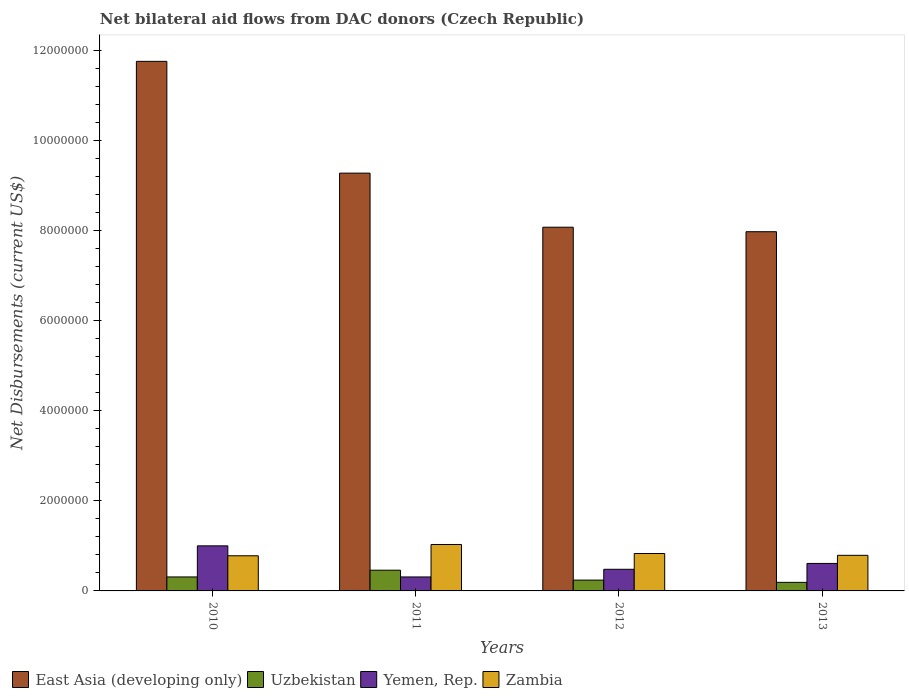How many different coloured bars are there?
Offer a terse response. 4. How many groups of bars are there?
Provide a short and direct response. 4. Are the number of bars per tick equal to the number of legend labels?
Offer a very short reply. Yes. How many bars are there on the 3rd tick from the left?
Offer a terse response. 4. What is the net bilateral aid flows in Uzbekistan in 2012?
Give a very brief answer. 2.40e+05. Across all years, what is the maximum net bilateral aid flows in East Asia (developing only)?
Make the answer very short. 1.18e+07. Across all years, what is the minimum net bilateral aid flows in Yemen, Rep.?
Provide a short and direct response. 3.10e+05. What is the total net bilateral aid flows in Zambia in the graph?
Your answer should be very brief. 3.43e+06. What is the difference between the net bilateral aid flows in East Asia (developing only) in 2010 and that in 2011?
Ensure brevity in your answer.  2.48e+06. What is the difference between the net bilateral aid flows in Yemen, Rep. in 2010 and the net bilateral aid flows in Uzbekistan in 2013?
Provide a succinct answer. 8.10e+05. What is the average net bilateral aid flows in East Asia (developing only) per year?
Your response must be concise. 9.26e+06. In the year 2011, what is the difference between the net bilateral aid flows in Zambia and net bilateral aid flows in Uzbekistan?
Offer a terse response. 5.70e+05. In how many years, is the net bilateral aid flows in Yemen, Rep. greater than 6800000 US$?
Your answer should be very brief. 0. What is the ratio of the net bilateral aid flows in Uzbekistan in 2010 to that in 2013?
Your response must be concise. 1.63. What is the difference between the highest and the lowest net bilateral aid flows in Yemen, Rep.?
Your response must be concise. 6.90e+05. In how many years, is the net bilateral aid flows in Uzbekistan greater than the average net bilateral aid flows in Uzbekistan taken over all years?
Your answer should be compact. 2. Is the sum of the net bilateral aid flows in Uzbekistan in 2010 and 2013 greater than the maximum net bilateral aid flows in East Asia (developing only) across all years?
Your answer should be very brief. No. What does the 4th bar from the left in 2010 represents?
Your answer should be compact. Zambia. What does the 3rd bar from the right in 2011 represents?
Offer a very short reply. Uzbekistan. Is it the case that in every year, the sum of the net bilateral aid flows in Yemen, Rep. and net bilateral aid flows in Zambia is greater than the net bilateral aid flows in East Asia (developing only)?
Provide a succinct answer. No. How many bars are there?
Make the answer very short. 16. How many years are there in the graph?
Your response must be concise. 4. Does the graph contain any zero values?
Your answer should be very brief. No. Where does the legend appear in the graph?
Your answer should be compact. Bottom left. How are the legend labels stacked?
Give a very brief answer. Horizontal. What is the title of the graph?
Keep it short and to the point. Net bilateral aid flows from DAC donors (Czech Republic). What is the label or title of the Y-axis?
Provide a short and direct response. Net Disbursements (current US$). What is the Net Disbursements (current US$) in East Asia (developing only) in 2010?
Your answer should be compact. 1.18e+07. What is the Net Disbursements (current US$) of Yemen, Rep. in 2010?
Ensure brevity in your answer.  1.00e+06. What is the Net Disbursements (current US$) of Zambia in 2010?
Give a very brief answer. 7.80e+05. What is the Net Disbursements (current US$) in East Asia (developing only) in 2011?
Make the answer very short. 9.27e+06. What is the Net Disbursements (current US$) of Uzbekistan in 2011?
Ensure brevity in your answer.  4.60e+05. What is the Net Disbursements (current US$) of Yemen, Rep. in 2011?
Offer a very short reply. 3.10e+05. What is the Net Disbursements (current US$) in Zambia in 2011?
Your response must be concise. 1.03e+06. What is the Net Disbursements (current US$) of East Asia (developing only) in 2012?
Your answer should be compact. 8.07e+06. What is the Net Disbursements (current US$) of Zambia in 2012?
Offer a terse response. 8.30e+05. What is the Net Disbursements (current US$) in East Asia (developing only) in 2013?
Give a very brief answer. 7.97e+06. What is the Net Disbursements (current US$) of Uzbekistan in 2013?
Offer a terse response. 1.90e+05. What is the Net Disbursements (current US$) in Zambia in 2013?
Ensure brevity in your answer.  7.90e+05. Across all years, what is the maximum Net Disbursements (current US$) of East Asia (developing only)?
Provide a short and direct response. 1.18e+07. Across all years, what is the maximum Net Disbursements (current US$) in Uzbekistan?
Offer a terse response. 4.60e+05. Across all years, what is the maximum Net Disbursements (current US$) in Yemen, Rep.?
Provide a short and direct response. 1.00e+06. Across all years, what is the maximum Net Disbursements (current US$) in Zambia?
Make the answer very short. 1.03e+06. Across all years, what is the minimum Net Disbursements (current US$) of East Asia (developing only)?
Offer a very short reply. 7.97e+06. Across all years, what is the minimum Net Disbursements (current US$) in Uzbekistan?
Ensure brevity in your answer.  1.90e+05. Across all years, what is the minimum Net Disbursements (current US$) in Zambia?
Offer a very short reply. 7.80e+05. What is the total Net Disbursements (current US$) of East Asia (developing only) in the graph?
Give a very brief answer. 3.71e+07. What is the total Net Disbursements (current US$) in Uzbekistan in the graph?
Your answer should be compact. 1.20e+06. What is the total Net Disbursements (current US$) of Yemen, Rep. in the graph?
Make the answer very short. 2.40e+06. What is the total Net Disbursements (current US$) of Zambia in the graph?
Ensure brevity in your answer.  3.43e+06. What is the difference between the Net Disbursements (current US$) in East Asia (developing only) in 2010 and that in 2011?
Give a very brief answer. 2.48e+06. What is the difference between the Net Disbursements (current US$) in Yemen, Rep. in 2010 and that in 2011?
Your answer should be compact. 6.90e+05. What is the difference between the Net Disbursements (current US$) in East Asia (developing only) in 2010 and that in 2012?
Your response must be concise. 3.68e+06. What is the difference between the Net Disbursements (current US$) in Uzbekistan in 2010 and that in 2012?
Your answer should be compact. 7.00e+04. What is the difference between the Net Disbursements (current US$) of Yemen, Rep. in 2010 and that in 2012?
Your answer should be very brief. 5.20e+05. What is the difference between the Net Disbursements (current US$) in Zambia in 2010 and that in 2012?
Provide a succinct answer. -5.00e+04. What is the difference between the Net Disbursements (current US$) in East Asia (developing only) in 2010 and that in 2013?
Ensure brevity in your answer.  3.78e+06. What is the difference between the Net Disbursements (current US$) in Zambia in 2010 and that in 2013?
Give a very brief answer. -10000. What is the difference between the Net Disbursements (current US$) in East Asia (developing only) in 2011 and that in 2012?
Your answer should be compact. 1.20e+06. What is the difference between the Net Disbursements (current US$) of Uzbekistan in 2011 and that in 2012?
Your answer should be compact. 2.20e+05. What is the difference between the Net Disbursements (current US$) of Yemen, Rep. in 2011 and that in 2012?
Provide a short and direct response. -1.70e+05. What is the difference between the Net Disbursements (current US$) of Zambia in 2011 and that in 2012?
Offer a very short reply. 2.00e+05. What is the difference between the Net Disbursements (current US$) of East Asia (developing only) in 2011 and that in 2013?
Give a very brief answer. 1.30e+06. What is the difference between the Net Disbursements (current US$) of Uzbekistan in 2011 and that in 2013?
Offer a very short reply. 2.70e+05. What is the difference between the Net Disbursements (current US$) of Zambia in 2011 and that in 2013?
Provide a succinct answer. 2.40e+05. What is the difference between the Net Disbursements (current US$) of East Asia (developing only) in 2012 and that in 2013?
Provide a succinct answer. 1.00e+05. What is the difference between the Net Disbursements (current US$) of Uzbekistan in 2012 and that in 2013?
Ensure brevity in your answer.  5.00e+04. What is the difference between the Net Disbursements (current US$) in Yemen, Rep. in 2012 and that in 2013?
Your answer should be compact. -1.30e+05. What is the difference between the Net Disbursements (current US$) of East Asia (developing only) in 2010 and the Net Disbursements (current US$) of Uzbekistan in 2011?
Your answer should be very brief. 1.13e+07. What is the difference between the Net Disbursements (current US$) in East Asia (developing only) in 2010 and the Net Disbursements (current US$) in Yemen, Rep. in 2011?
Provide a succinct answer. 1.14e+07. What is the difference between the Net Disbursements (current US$) in East Asia (developing only) in 2010 and the Net Disbursements (current US$) in Zambia in 2011?
Provide a short and direct response. 1.07e+07. What is the difference between the Net Disbursements (current US$) in Uzbekistan in 2010 and the Net Disbursements (current US$) in Zambia in 2011?
Keep it short and to the point. -7.20e+05. What is the difference between the Net Disbursements (current US$) in Yemen, Rep. in 2010 and the Net Disbursements (current US$) in Zambia in 2011?
Offer a terse response. -3.00e+04. What is the difference between the Net Disbursements (current US$) in East Asia (developing only) in 2010 and the Net Disbursements (current US$) in Uzbekistan in 2012?
Your answer should be very brief. 1.15e+07. What is the difference between the Net Disbursements (current US$) in East Asia (developing only) in 2010 and the Net Disbursements (current US$) in Yemen, Rep. in 2012?
Your answer should be compact. 1.13e+07. What is the difference between the Net Disbursements (current US$) in East Asia (developing only) in 2010 and the Net Disbursements (current US$) in Zambia in 2012?
Your answer should be compact. 1.09e+07. What is the difference between the Net Disbursements (current US$) in Uzbekistan in 2010 and the Net Disbursements (current US$) in Yemen, Rep. in 2012?
Ensure brevity in your answer.  -1.70e+05. What is the difference between the Net Disbursements (current US$) of Uzbekistan in 2010 and the Net Disbursements (current US$) of Zambia in 2012?
Ensure brevity in your answer.  -5.20e+05. What is the difference between the Net Disbursements (current US$) in Yemen, Rep. in 2010 and the Net Disbursements (current US$) in Zambia in 2012?
Provide a succinct answer. 1.70e+05. What is the difference between the Net Disbursements (current US$) of East Asia (developing only) in 2010 and the Net Disbursements (current US$) of Uzbekistan in 2013?
Your answer should be compact. 1.16e+07. What is the difference between the Net Disbursements (current US$) in East Asia (developing only) in 2010 and the Net Disbursements (current US$) in Yemen, Rep. in 2013?
Give a very brief answer. 1.11e+07. What is the difference between the Net Disbursements (current US$) in East Asia (developing only) in 2010 and the Net Disbursements (current US$) in Zambia in 2013?
Ensure brevity in your answer.  1.10e+07. What is the difference between the Net Disbursements (current US$) of Uzbekistan in 2010 and the Net Disbursements (current US$) of Yemen, Rep. in 2013?
Your response must be concise. -3.00e+05. What is the difference between the Net Disbursements (current US$) in Uzbekistan in 2010 and the Net Disbursements (current US$) in Zambia in 2013?
Offer a terse response. -4.80e+05. What is the difference between the Net Disbursements (current US$) in East Asia (developing only) in 2011 and the Net Disbursements (current US$) in Uzbekistan in 2012?
Keep it short and to the point. 9.03e+06. What is the difference between the Net Disbursements (current US$) of East Asia (developing only) in 2011 and the Net Disbursements (current US$) of Yemen, Rep. in 2012?
Provide a succinct answer. 8.79e+06. What is the difference between the Net Disbursements (current US$) of East Asia (developing only) in 2011 and the Net Disbursements (current US$) of Zambia in 2012?
Make the answer very short. 8.44e+06. What is the difference between the Net Disbursements (current US$) of Uzbekistan in 2011 and the Net Disbursements (current US$) of Zambia in 2012?
Your answer should be compact. -3.70e+05. What is the difference between the Net Disbursements (current US$) of Yemen, Rep. in 2011 and the Net Disbursements (current US$) of Zambia in 2012?
Your answer should be compact. -5.20e+05. What is the difference between the Net Disbursements (current US$) in East Asia (developing only) in 2011 and the Net Disbursements (current US$) in Uzbekistan in 2013?
Your answer should be compact. 9.08e+06. What is the difference between the Net Disbursements (current US$) in East Asia (developing only) in 2011 and the Net Disbursements (current US$) in Yemen, Rep. in 2013?
Provide a short and direct response. 8.66e+06. What is the difference between the Net Disbursements (current US$) in East Asia (developing only) in 2011 and the Net Disbursements (current US$) in Zambia in 2013?
Offer a very short reply. 8.48e+06. What is the difference between the Net Disbursements (current US$) of Uzbekistan in 2011 and the Net Disbursements (current US$) of Yemen, Rep. in 2013?
Your answer should be compact. -1.50e+05. What is the difference between the Net Disbursements (current US$) in Uzbekistan in 2011 and the Net Disbursements (current US$) in Zambia in 2013?
Offer a very short reply. -3.30e+05. What is the difference between the Net Disbursements (current US$) of Yemen, Rep. in 2011 and the Net Disbursements (current US$) of Zambia in 2013?
Ensure brevity in your answer.  -4.80e+05. What is the difference between the Net Disbursements (current US$) of East Asia (developing only) in 2012 and the Net Disbursements (current US$) of Uzbekistan in 2013?
Your answer should be compact. 7.88e+06. What is the difference between the Net Disbursements (current US$) in East Asia (developing only) in 2012 and the Net Disbursements (current US$) in Yemen, Rep. in 2013?
Offer a terse response. 7.46e+06. What is the difference between the Net Disbursements (current US$) of East Asia (developing only) in 2012 and the Net Disbursements (current US$) of Zambia in 2013?
Provide a succinct answer. 7.28e+06. What is the difference between the Net Disbursements (current US$) of Uzbekistan in 2012 and the Net Disbursements (current US$) of Yemen, Rep. in 2013?
Offer a terse response. -3.70e+05. What is the difference between the Net Disbursements (current US$) in Uzbekistan in 2012 and the Net Disbursements (current US$) in Zambia in 2013?
Ensure brevity in your answer.  -5.50e+05. What is the difference between the Net Disbursements (current US$) of Yemen, Rep. in 2012 and the Net Disbursements (current US$) of Zambia in 2013?
Make the answer very short. -3.10e+05. What is the average Net Disbursements (current US$) of East Asia (developing only) per year?
Your response must be concise. 9.26e+06. What is the average Net Disbursements (current US$) of Zambia per year?
Your answer should be compact. 8.58e+05. In the year 2010, what is the difference between the Net Disbursements (current US$) in East Asia (developing only) and Net Disbursements (current US$) in Uzbekistan?
Keep it short and to the point. 1.14e+07. In the year 2010, what is the difference between the Net Disbursements (current US$) in East Asia (developing only) and Net Disbursements (current US$) in Yemen, Rep.?
Keep it short and to the point. 1.08e+07. In the year 2010, what is the difference between the Net Disbursements (current US$) of East Asia (developing only) and Net Disbursements (current US$) of Zambia?
Ensure brevity in your answer.  1.10e+07. In the year 2010, what is the difference between the Net Disbursements (current US$) of Uzbekistan and Net Disbursements (current US$) of Yemen, Rep.?
Give a very brief answer. -6.90e+05. In the year 2010, what is the difference between the Net Disbursements (current US$) of Uzbekistan and Net Disbursements (current US$) of Zambia?
Ensure brevity in your answer.  -4.70e+05. In the year 2011, what is the difference between the Net Disbursements (current US$) of East Asia (developing only) and Net Disbursements (current US$) of Uzbekistan?
Provide a succinct answer. 8.81e+06. In the year 2011, what is the difference between the Net Disbursements (current US$) in East Asia (developing only) and Net Disbursements (current US$) in Yemen, Rep.?
Make the answer very short. 8.96e+06. In the year 2011, what is the difference between the Net Disbursements (current US$) in East Asia (developing only) and Net Disbursements (current US$) in Zambia?
Provide a short and direct response. 8.24e+06. In the year 2011, what is the difference between the Net Disbursements (current US$) of Uzbekistan and Net Disbursements (current US$) of Zambia?
Your answer should be very brief. -5.70e+05. In the year 2011, what is the difference between the Net Disbursements (current US$) of Yemen, Rep. and Net Disbursements (current US$) of Zambia?
Provide a succinct answer. -7.20e+05. In the year 2012, what is the difference between the Net Disbursements (current US$) in East Asia (developing only) and Net Disbursements (current US$) in Uzbekistan?
Your response must be concise. 7.83e+06. In the year 2012, what is the difference between the Net Disbursements (current US$) of East Asia (developing only) and Net Disbursements (current US$) of Yemen, Rep.?
Your answer should be very brief. 7.59e+06. In the year 2012, what is the difference between the Net Disbursements (current US$) of East Asia (developing only) and Net Disbursements (current US$) of Zambia?
Offer a very short reply. 7.24e+06. In the year 2012, what is the difference between the Net Disbursements (current US$) of Uzbekistan and Net Disbursements (current US$) of Yemen, Rep.?
Provide a succinct answer. -2.40e+05. In the year 2012, what is the difference between the Net Disbursements (current US$) of Uzbekistan and Net Disbursements (current US$) of Zambia?
Your answer should be very brief. -5.90e+05. In the year 2012, what is the difference between the Net Disbursements (current US$) in Yemen, Rep. and Net Disbursements (current US$) in Zambia?
Your response must be concise. -3.50e+05. In the year 2013, what is the difference between the Net Disbursements (current US$) in East Asia (developing only) and Net Disbursements (current US$) in Uzbekistan?
Provide a succinct answer. 7.78e+06. In the year 2013, what is the difference between the Net Disbursements (current US$) of East Asia (developing only) and Net Disbursements (current US$) of Yemen, Rep.?
Ensure brevity in your answer.  7.36e+06. In the year 2013, what is the difference between the Net Disbursements (current US$) of East Asia (developing only) and Net Disbursements (current US$) of Zambia?
Offer a very short reply. 7.18e+06. In the year 2013, what is the difference between the Net Disbursements (current US$) in Uzbekistan and Net Disbursements (current US$) in Yemen, Rep.?
Ensure brevity in your answer.  -4.20e+05. In the year 2013, what is the difference between the Net Disbursements (current US$) of Uzbekistan and Net Disbursements (current US$) of Zambia?
Offer a terse response. -6.00e+05. In the year 2013, what is the difference between the Net Disbursements (current US$) in Yemen, Rep. and Net Disbursements (current US$) in Zambia?
Keep it short and to the point. -1.80e+05. What is the ratio of the Net Disbursements (current US$) of East Asia (developing only) in 2010 to that in 2011?
Keep it short and to the point. 1.27. What is the ratio of the Net Disbursements (current US$) in Uzbekistan in 2010 to that in 2011?
Give a very brief answer. 0.67. What is the ratio of the Net Disbursements (current US$) of Yemen, Rep. in 2010 to that in 2011?
Offer a terse response. 3.23. What is the ratio of the Net Disbursements (current US$) in Zambia in 2010 to that in 2011?
Offer a very short reply. 0.76. What is the ratio of the Net Disbursements (current US$) of East Asia (developing only) in 2010 to that in 2012?
Provide a short and direct response. 1.46. What is the ratio of the Net Disbursements (current US$) of Uzbekistan in 2010 to that in 2012?
Offer a terse response. 1.29. What is the ratio of the Net Disbursements (current US$) of Yemen, Rep. in 2010 to that in 2012?
Give a very brief answer. 2.08. What is the ratio of the Net Disbursements (current US$) in Zambia in 2010 to that in 2012?
Your answer should be compact. 0.94. What is the ratio of the Net Disbursements (current US$) of East Asia (developing only) in 2010 to that in 2013?
Your answer should be very brief. 1.47. What is the ratio of the Net Disbursements (current US$) in Uzbekistan in 2010 to that in 2013?
Offer a terse response. 1.63. What is the ratio of the Net Disbursements (current US$) of Yemen, Rep. in 2010 to that in 2013?
Offer a very short reply. 1.64. What is the ratio of the Net Disbursements (current US$) in Zambia in 2010 to that in 2013?
Your answer should be very brief. 0.99. What is the ratio of the Net Disbursements (current US$) in East Asia (developing only) in 2011 to that in 2012?
Your answer should be very brief. 1.15. What is the ratio of the Net Disbursements (current US$) of Uzbekistan in 2011 to that in 2012?
Your answer should be compact. 1.92. What is the ratio of the Net Disbursements (current US$) of Yemen, Rep. in 2011 to that in 2012?
Give a very brief answer. 0.65. What is the ratio of the Net Disbursements (current US$) of Zambia in 2011 to that in 2012?
Keep it short and to the point. 1.24. What is the ratio of the Net Disbursements (current US$) of East Asia (developing only) in 2011 to that in 2013?
Provide a short and direct response. 1.16. What is the ratio of the Net Disbursements (current US$) in Uzbekistan in 2011 to that in 2013?
Your response must be concise. 2.42. What is the ratio of the Net Disbursements (current US$) in Yemen, Rep. in 2011 to that in 2013?
Your response must be concise. 0.51. What is the ratio of the Net Disbursements (current US$) of Zambia in 2011 to that in 2013?
Offer a very short reply. 1.3. What is the ratio of the Net Disbursements (current US$) in East Asia (developing only) in 2012 to that in 2013?
Your response must be concise. 1.01. What is the ratio of the Net Disbursements (current US$) in Uzbekistan in 2012 to that in 2013?
Your answer should be very brief. 1.26. What is the ratio of the Net Disbursements (current US$) of Yemen, Rep. in 2012 to that in 2013?
Your response must be concise. 0.79. What is the ratio of the Net Disbursements (current US$) in Zambia in 2012 to that in 2013?
Give a very brief answer. 1.05. What is the difference between the highest and the second highest Net Disbursements (current US$) of East Asia (developing only)?
Your answer should be very brief. 2.48e+06. What is the difference between the highest and the second highest Net Disbursements (current US$) in Uzbekistan?
Make the answer very short. 1.50e+05. What is the difference between the highest and the second highest Net Disbursements (current US$) of Yemen, Rep.?
Your answer should be very brief. 3.90e+05. What is the difference between the highest and the second highest Net Disbursements (current US$) in Zambia?
Your response must be concise. 2.00e+05. What is the difference between the highest and the lowest Net Disbursements (current US$) of East Asia (developing only)?
Provide a short and direct response. 3.78e+06. What is the difference between the highest and the lowest Net Disbursements (current US$) in Uzbekistan?
Give a very brief answer. 2.70e+05. What is the difference between the highest and the lowest Net Disbursements (current US$) of Yemen, Rep.?
Your answer should be compact. 6.90e+05. What is the difference between the highest and the lowest Net Disbursements (current US$) of Zambia?
Offer a terse response. 2.50e+05. 